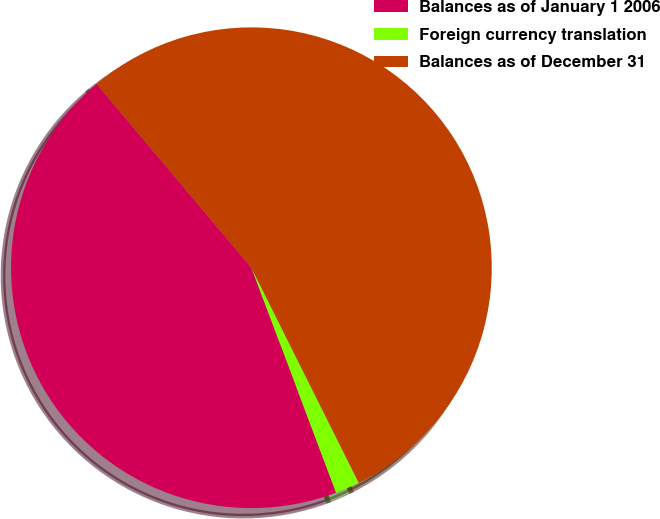Convert chart. <chart><loc_0><loc_0><loc_500><loc_500><pie_chart><fcel>Balances as of January 1 2006<fcel>Foreign currency translation<fcel>Balances as of December 31<nl><fcel>44.59%<fcel>1.64%<fcel>53.77%<nl></chart> 